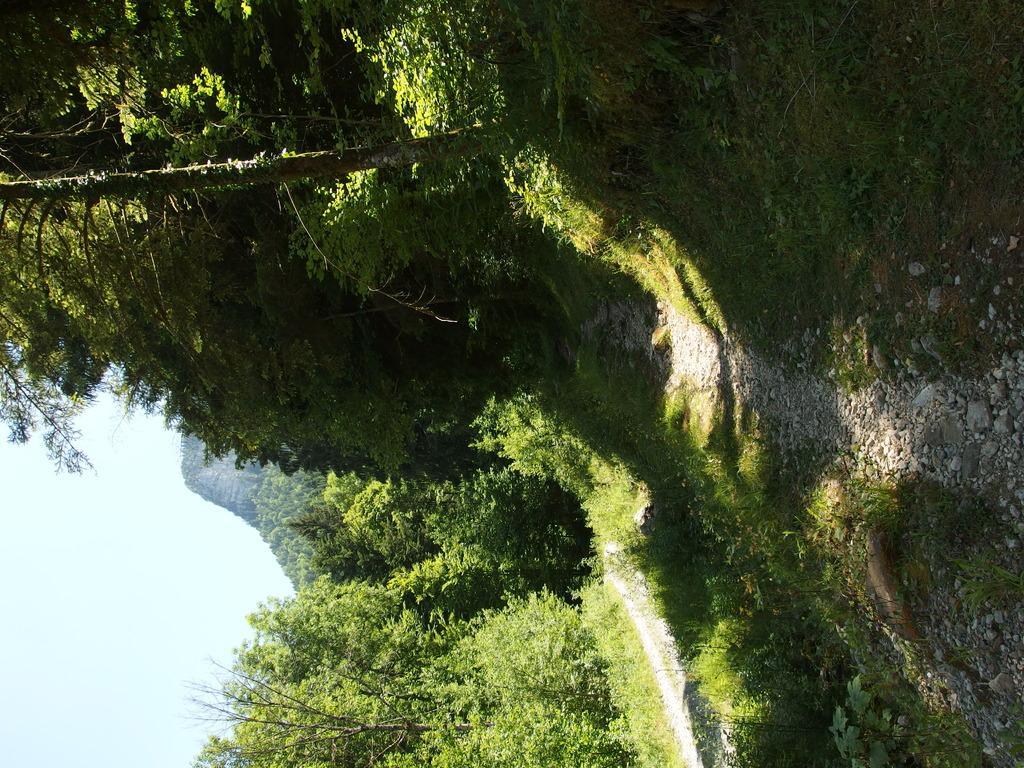Describe this image in one or two sentences. In this image there is a sky, there are plants, there are trees, there is grass, there are stones. 